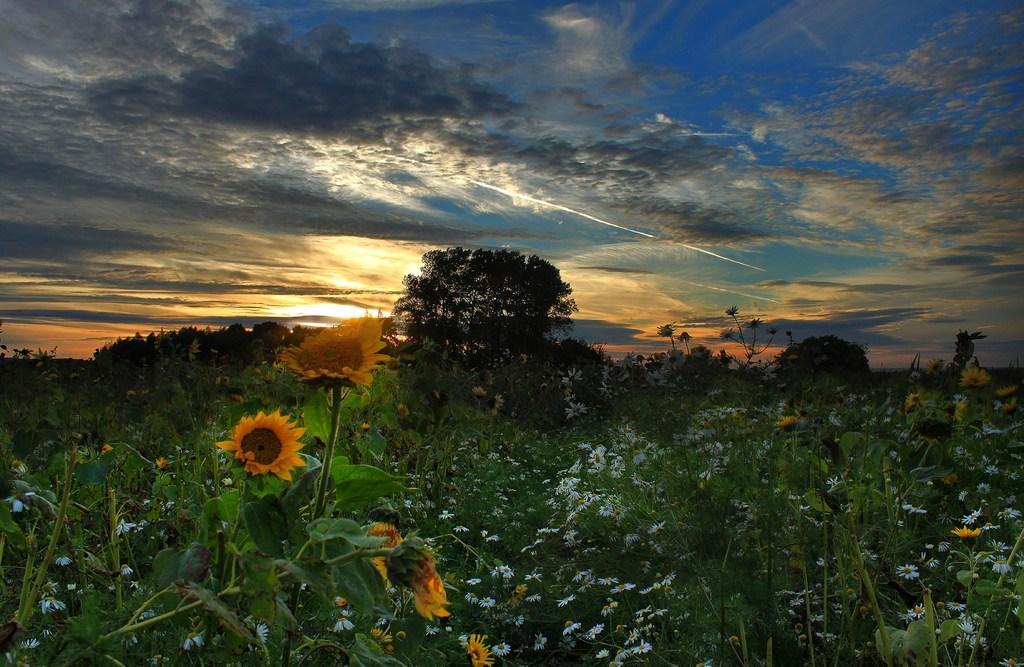Describe this image in one or two sentences. IN this image we can see some flowers, plants, trees, and the sky. 